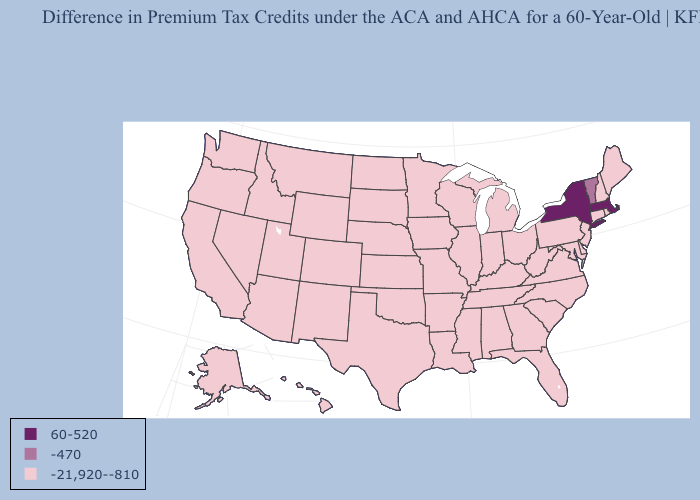Does Pennsylvania have a lower value than Vermont?
Be succinct. Yes. Does Mississippi have the same value as Vermont?
Keep it brief. No. Does the first symbol in the legend represent the smallest category?
Concise answer only. No. Name the states that have a value in the range -470?
Be succinct. Vermont. What is the value of Alabama?
Give a very brief answer. -21,920--810. Does Virginia have a lower value than New York?
Keep it brief. Yes. Which states hav the highest value in the MidWest?
Quick response, please. Illinois, Indiana, Iowa, Kansas, Michigan, Minnesota, Missouri, Nebraska, North Dakota, Ohio, South Dakota, Wisconsin. Does Michigan have the same value as New York?
Write a very short answer. No. Among the states that border Missouri , which have the lowest value?
Concise answer only. Arkansas, Illinois, Iowa, Kansas, Kentucky, Nebraska, Oklahoma, Tennessee. Name the states that have a value in the range -21,920--810?
Be succinct. Alabama, Alaska, Arizona, Arkansas, California, Colorado, Connecticut, Delaware, Florida, Georgia, Hawaii, Idaho, Illinois, Indiana, Iowa, Kansas, Kentucky, Louisiana, Maine, Maryland, Michigan, Minnesota, Mississippi, Missouri, Montana, Nebraska, Nevada, New Hampshire, New Jersey, New Mexico, North Carolina, North Dakota, Ohio, Oklahoma, Oregon, Pennsylvania, Rhode Island, South Carolina, South Dakota, Tennessee, Texas, Utah, Virginia, Washington, West Virginia, Wisconsin, Wyoming. Does Indiana have a lower value than Florida?
Be succinct. No. Name the states that have a value in the range -21,920--810?
Short answer required. Alabama, Alaska, Arizona, Arkansas, California, Colorado, Connecticut, Delaware, Florida, Georgia, Hawaii, Idaho, Illinois, Indiana, Iowa, Kansas, Kentucky, Louisiana, Maine, Maryland, Michigan, Minnesota, Mississippi, Missouri, Montana, Nebraska, Nevada, New Hampshire, New Jersey, New Mexico, North Carolina, North Dakota, Ohio, Oklahoma, Oregon, Pennsylvania, Rhode Island, South Carolina, South Dakota, Tennessee, Texas, Utah, Virginia, Washington, West Virginia, Wisconsin, Wyoming. What is the highest value in the West ?
Keep it brief. -21,920--810. Name the states that have a value in the range -470?
Concise answer only. Vermont. What is the value of New Jersey?
Short answer required. -21,920--810. 